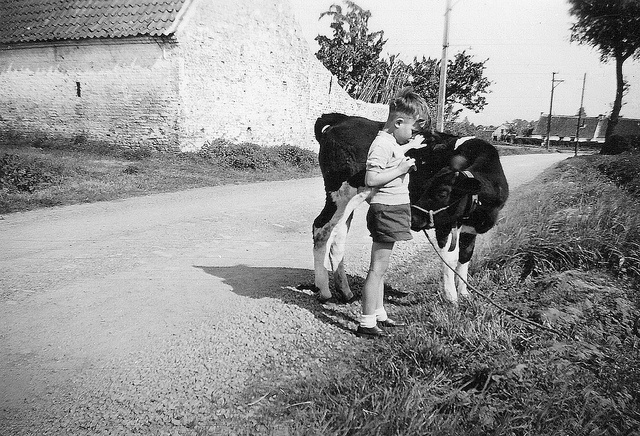Describe the objects in this image and their specific colors. I can see cow in gray, black, gainsboro, and darkgray tones and people in gray, lightgray, darkgray, and black tones in this image. 